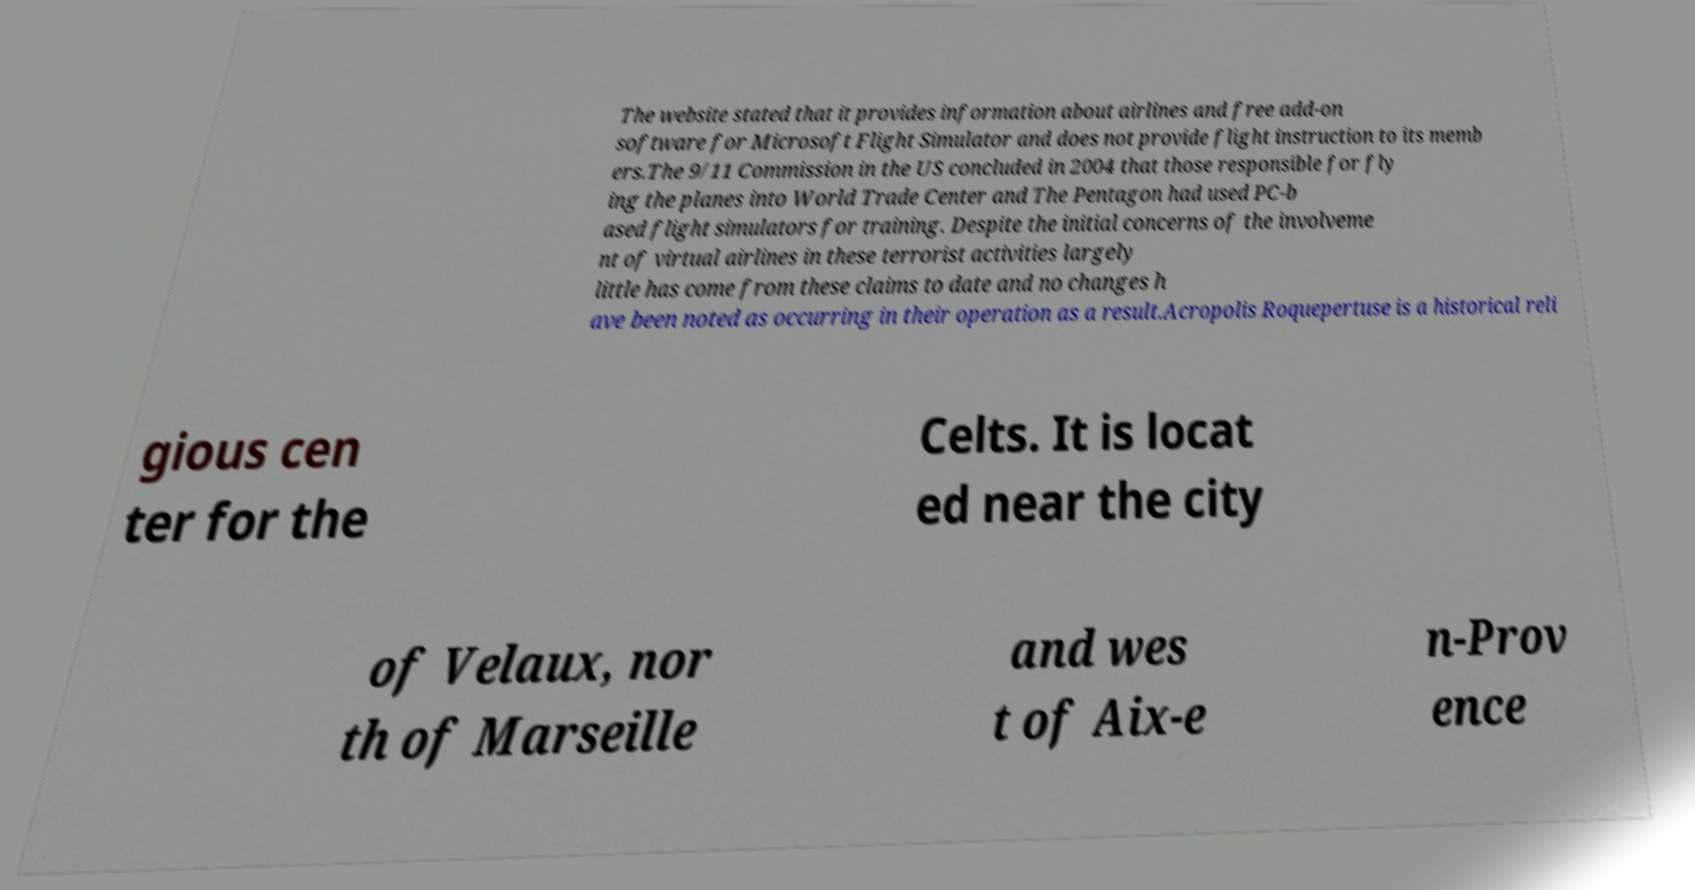For documentation purposes, I need the text within this image transcribed. Could you provide that? The website stated that it provides information about airlines and free add-on software for Microsoft Flight Simulator and does not provide flight instruction to its memb ers.The 9/11 Commission in the US concluded in 2004 that those responsible for fly ing the planes into World Trade Center and The Pentagon had used PC-b ased flight simulators for training. Despite the initial concerns of the involveme nt of virtual airlines in these terrorist activities largely little has come from these claims to date and no changes h ave been noted as occurring in their operation as a result.Acropolis Roquepertuse is a historical reli gious cen ter for the Celts. It is locat ed near the city of Velaux, nor th of Marseille and wes t of Aix-e n-Prov ence 